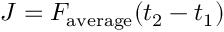Convert formula to latex. <formula><loc_0><loc_0><loc_500><loc_500>J = F _ { a v e r a g e } ( t _ { 2 } - t _ { 1 } )</formula> 